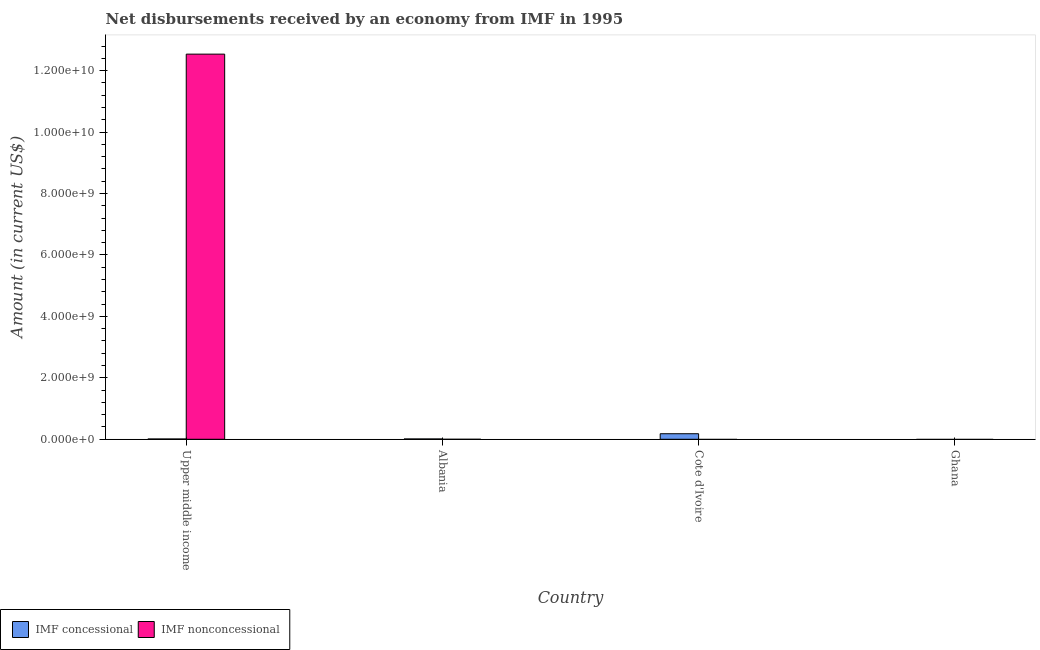How many different coloured bars are there?
Ensure brevity in your answer.  2. Are the number of bars on each tick of the X-axis equal?
Keep it short and to the point. No. How many bars are there on the 3rd tick from the left?
Ensure brevity in your answer.  1. How many bars are there on the 1st tick from the right?
Your answer should be compact. 0. What is the label of the 1st group of bars from the left?
Provide a succinct answer. Upper middle income. What is the net concessional disbursements from imf in Upper middle income?
Make the answer very short. 9.86e+06. Across all countries, what is the maximum net concessional disbursements from imf?
Keep it short and to the point. 1.81e+08. In which country was the net non concessional disbursements from imf maximum?
Your response must be concise. Upper middle income. What is the total net non concessional disbursements from imf in the graph?
Ensure brevity in your answer.  1.25e+1. What is the difference between the net non concessional disbursements from imf in Ghana and the net concessional disbursements from imf in Cote d'Ivoire?
Provide a succinct answer. -1.81e+08. What is the average net non concessional disbursements from imf per country?
Your response must be concise. 3.13e+09. What is the difference between the net concessional disbursements from imf and net non concessional disbursements from imf in Upper middle income?
Provide a short and direct response. -1.25e+1. In how many countries, is the net non concessional disbursements from imf greater than 2000000000 US$?
Make the answer very short. 1. What is the difference between the highest and the second highest net concessional disbursements from imf?
Your answer should be very brief. 1.70e+08. What is the difference between the highest and the lowest net concessional disbursements from imf?
Make the answer very short. 1.81e+08. In how many countries, is the net non concessional disbursements from imf greater than the average net non concessional disbursements from imf taken over all countries?
Your answer should be compact. 1. How many countries are there in the graph?
Offer a very short reply. 4. Does the graph contain any zero values?
Your answer should be very brief. Yes. Where does the legend appear in the graph?
Offer a terse response. Bottom left. How many legend labels are there?
Your response must be concise. 2. What is the title of the graph?
Your response must be concise. Net disbursements received by an economy from IMF in 1995. Does "Non-residents" appear as one of the legend labels in the graph?
Keep it short and to the point. No. What is the Amount (in current US$) in IMF concessional in Upper middle income?
Provide a short and direct response. 9.86e+06. What is the Amount (in current US$) in IMF nonconcessional in Upper middle income?
Keep it short and to the point. 1.25e+1. What is the Amount (in current US$) of IMF concessional in Albania?
Give a very brief answer. 1.07e+07. What is the Amount (in current US$) in IMF concessional in Cote d'Ivoire?
Your answer should be very brief. 1.81e+08. What is the Amount (in current US$) of IMF concessional in Ghana?
Your response must be concise. 0. Across all countries, what is the maximum Amount (in current US$) of IMF concessional?
Give a very brief answer. 1.81e+08. Across all countries, what is the maximum Amount (in current US$) in IMF nonconcessional?
Ensure brevity in your answer.  1.25e+1. Across all countries, what is the minimum Amount (in current US$) in IMF concessional?
Make the answer very short. 0. What is the total Amount (in current US$) in IMF concessional in the graph?
Make the answer very short. 2.01e+08. What is the total Amount (in current US$) in IMF nonconcessional in the graph?
Provide a succinct answer. 1.25e+1. What is the difference between the Amount (in current US$) of IMF concessional in Upper middle income and that in Albania?
Provide a short and direct response. -8.50e+05. What is the difference between the Amount (in current US$) in IMF concessional in Upper middle income and that in Cote d'Ivoire?
Your answer should be compact. -1.71e+08. What is the difference between the Amount (in current US$) of IMF concessional in Albania and that in Cote d'Ivoire?
Make the answer very short. -1.70e+08. What is the average Amount (in current US$) in IMF concessional per country?
Your response must be concise. 5.03e+07. What is the average Amount (in current US$) in IMF nonconcessional per country?
Your response must be concise. 3.13e+09. What is the difference between the Amount (in current US$) of IMF concessional and Amount (in current US$) of IMF nonconcessional in Upper middle income?
Your response must be concise. -1.25e+1. What is the ratio of the Amount (in current US$) in IMF concessional in Upper middle income to that in Albania?
Ensure brevity in your answer.  0.92. What is the ratio of the Amount (in current US$) in IMF concessional in Upper middle income to that in Cote d'Ivoire?
Keep it short and to the point. 0.05. What is the ratio of the Amount (in current US$) of IMF concessional in Albania to that in Cote d'Ivoire?
Ensure brevity in your answer.  0.06. What is the difference between the highest and the second highest Amount (in current US$) in IMF concessional?
Provide a succinct answer. 1.70e+08. What is the difference between the highest and the lowest Amount (in current US$) in IMF concessional?
Give a very brief answer. 1.81e+08. What is the difference between the highest and the lowest Amount (in current US$) in IMF nonconcessional?
Ensure brevity in your answer.  1.25e+1. 